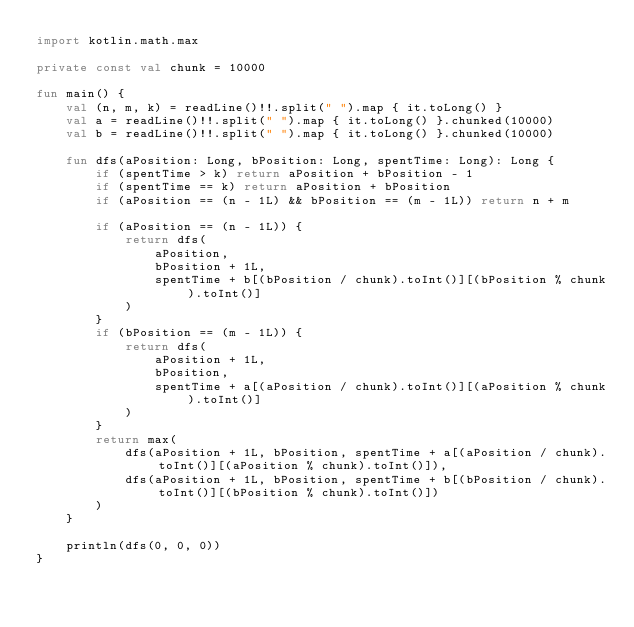Convert code to text. <code><loc_0><loc_0><loc_500><loc_500><_Kotlin_>import kotlin.math.max

private const val chunk = 10000

fun main() {
    val (n, m, k) = readLine()!!.split(" ").map { it.toLong() }
    val a = readLine()!!.split(" ").map { it.toLong() }.chunked(10000)
    val b = readLine()!!.split(" ").map { it.toLong() }.chunked(10000)

    fun dfs(aPosition: Long, bPosition: Long, spentTime: Long): Long {
        if (spentTime > k) return aPosition + bPosition - 1
        if (spentTime == k) return aPosition + bPosition
        if (aPosition == (n - 1L) && bPosition == (m - 1L)) return n + m

        if (aPosition == (n - 1L)) {
            return dfs(
                aPosition,
                bPosition + 1L,
                spentTime + b[(bPosition / chunk).toInt()][(bPosition % chunk).toInt()]
            )
        }
        if (bPosition == (m - 1L)) {
            return dfs(
                aPosition + 1L,
                bPosition,
                spentTime + a[(aPosition / chunk).toInt()][(aPosition % chunk).toInt()]
            )
        }
        return max(
            dfs(aPosition + 1L, bPosition, spentTime + a[(aPosition / chunk).toInt()][(aPosition % chunk).toInt()]),
            dfs(aPosition + 1L, bPosition, spentTime + b[(bPosition / chunk).toInt()][(bPosition % chunk).toInt()])
        )
    }

    println(dfs(0, 0, 0))
}
</code> 